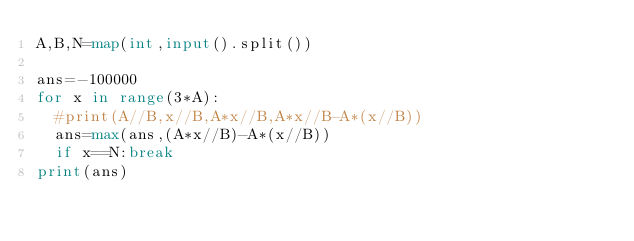<code> <loc_0><loc_0><loc_500><loc_500><_Python_>A,B,N=map(int,input().split())

ans=-100000
for x in range(3*A):
  #print(A//B,x//B,A*x//B,A*x//B-A*(x//B))
  ans=max(ans,(A*x//B)-A*(x//B))
  if x==N:break
print(ans)</code> 